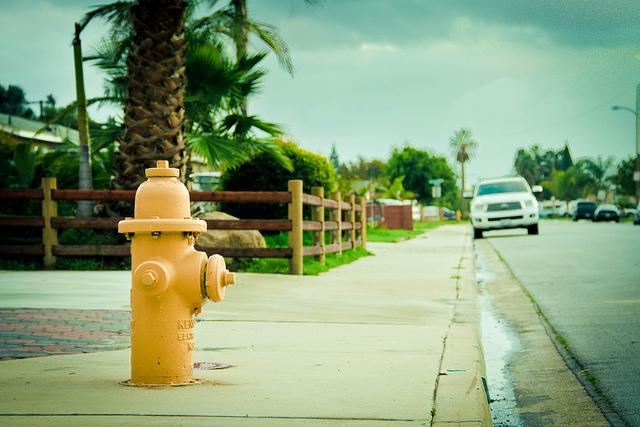What type of vehicle in the distance?
Short answer required. Truck. What color is the fire hydrant?
Concise answer only. Yellow. How many poles in the fence?
Keep it brief. 6. Are there cars parked on the street?
Give a very brief answer. Yes. 